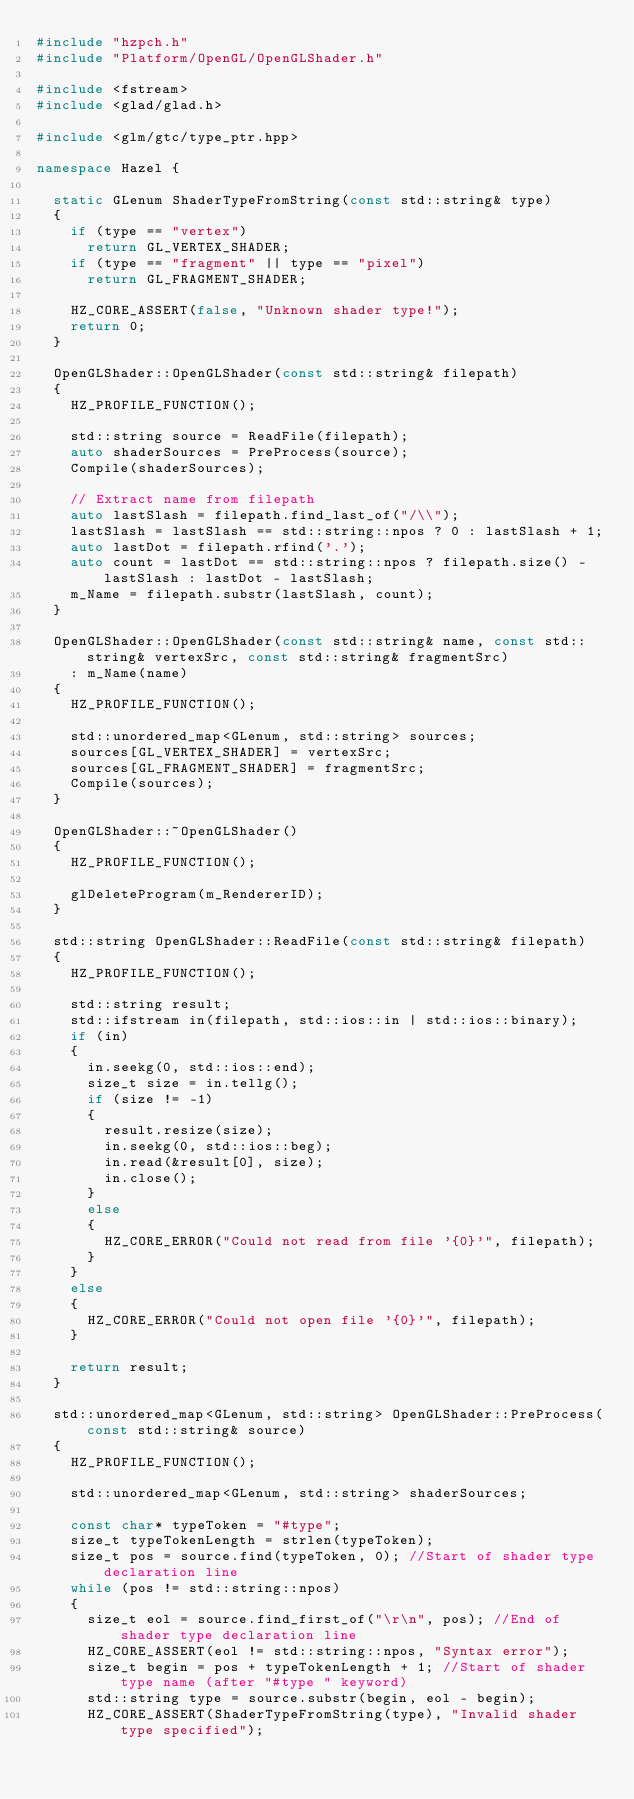<code> <loc_0><loc_0><loc_500><loc_500><_C++_>#include "hzpch.h"
#include "Platform/OpenGL/OpenGLShader.h"

#include <fstream>
#include <glad/glad.h>

#include <glm/gtc/type_ptr.hpp>

namespace Hazel {

	static GLenum ShaderTypeFromString(const std::string& type)
	{
		if (type == "vertex")
			return GL_VERTEX_SHADER;
		if (type == "fragment" || type == "pixel")
			return GL_FRAGMENT_SHADER;

		HZ_CORE_ASSERT(false, "Unknown shader type!");
		return 0;
	}

	OpenGLShader::OpenGLShader(const std::string& filepath)
	{
		HZ_PROFILE_FUNCTION();

		std::string source = ReadFile(filepath);
		auto shaderSources = PreProcess(source);
		Compile(shaderSources);

		// Extract name from filepath
		auto lastSlash = filepath.find_last_of("/\\");
		lastSlash = lastSlash == std::string::npos ? 0 : lastSlash + 1;
		auto lastDot = filepath.rfind('.');
		auto count = lastDot == std::string::npos ? filepath.size() - lastSlash : lastDot - lastSlash;
		m_Name = filepath.substr(lastSlash, count);
	}

	OpenGLShader::OpenGLShader(const std::string& name, const std::string& vertexSrc, const std::string& fragmentSrc)
		: m_Name(name)
	{
		HZ_PROFILE_FUNCTION();

		std::unordered_map<GLenum, std::string> sources;
		sources[GL_VERTEX_SHADER] = vertexSrc;
		sources[GL_FRAGMENT_SHADER] = fragmentSrc;
		Compile(sources);
	}

	OpenGLShader::~OpenGLShader()
	{
		HZ_PROFILE_FUNCTION();

		glDeleteProgram(m_RendererID);
	}

	std::string OpenGLShader::ReadFile(const std::string& filepath)
	{
		HZ_PROFILE_FUNCTION();

		std::string result;
		std::ifstream in(filepath, std::ios::in | std::ios::binary);
		if (in)
		{
			in.seekg(0, std::ios::end);
			size_t size = in.tellg();
			if (size != -1)
			{
				result.resize(size);
				in.seekg(0, std::ios::beg);
				in.read(&result[0], size);
				in.close();
			}
			else
			{
				HZ_CORE_ERROR("Could not read from file '{0}'", filepath);
			}
		}
		else
		{
			HZ_CORE_ERROR("Could not open file '{0}'", filepath);
		}

		return result;
	}

	std::unordered_map<GLenum, std::string> OpenGLShader::PreProcess(const std::string& source)
	{
		HZ_PROFILE_FUNCTION();

		std::unordered_map<GLenum, std::string> shaderSources;

		const char* typeToken = "#type";
		size_t typeTokenLength = strlen(typeToken);
		size_t pos = source.find(typeToken, 0); //Start of shader type declaration line
		while (pos != std::string::npos)
		{
			size_t eol = source.find_first_of("\r\n", pos); //End of shader type declaration line
			HZ_CORE_ASSERT(eol != std::string::npos, "Syntax error");
			size_t begin = pos + typeTokenLength + 1; //Start of shader type name (after "#type " keyword)
			std::string type = source.substr(begin, eol - begin);
			HZ_CORE_ASSERT(ShaderTypeFromString(type), "Invalid shader type specified");
</code> 